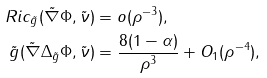Convert formula to latex. <formula><loc_0><loc_0><loc_500><loc_500>R i c _ { \tilde { g } } ( \tilde { \nabla } \Phi , \tilde { \nu } ) & = o ( \rho ^ { - 3 } ) , \\ \tilde { g } ( \tilde { \nabla } \Delta _ { \tilde { g } } \Phi , \tilde { \nu } ) & = \frac { 8 ( 1 - \alpha ) } { \rho ^ { 3 } } + O _ { 1 } ( \rho ^ { - 4 } ) ,</formula> 